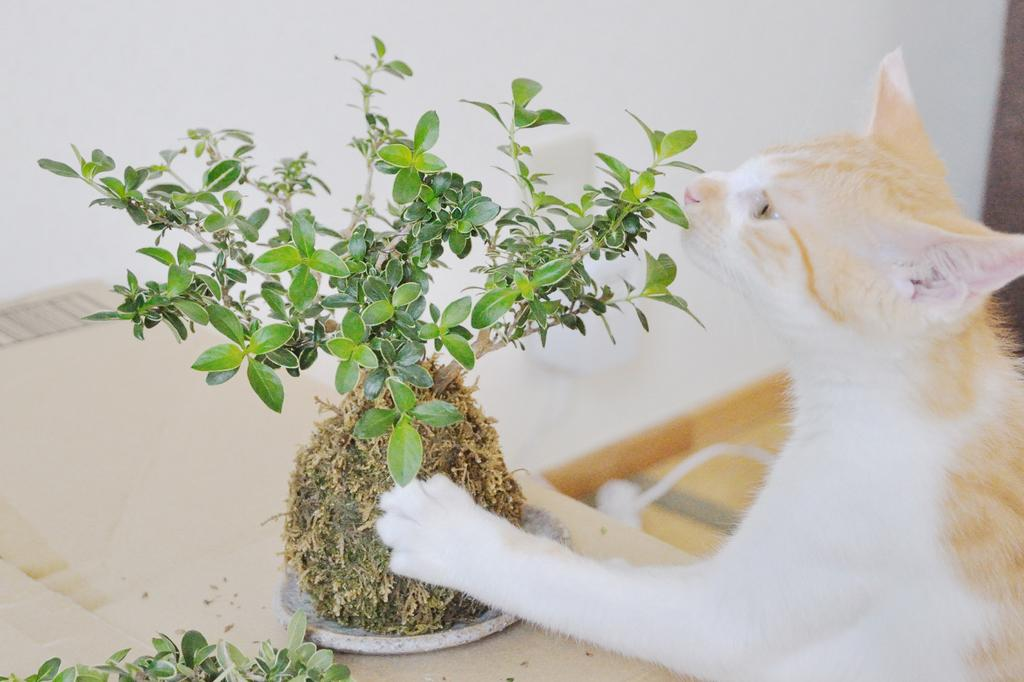What is the main piece of furniture in the image? There is a table in the image. Are there any objects on the table? Yes, there is a plant on the table. What is the cat doing in the image? The cat is touching the plant. What type of wire is connected to the oven in the image? There is no oven present in the image, so there is no wire connected to it. 